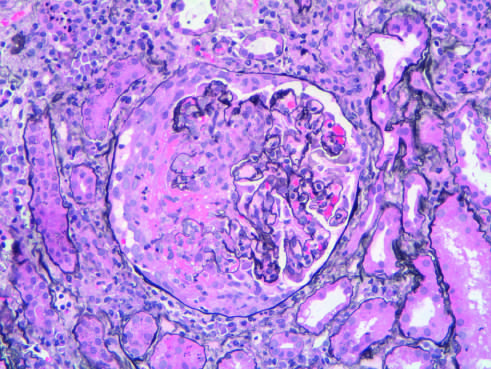s a characteristic tubercle at low magnification typical of anca anti-neutrophil cytoplasmic antibody - associated crescentic glomerulonephritis?
Answer the question using a single word or phrase. No 